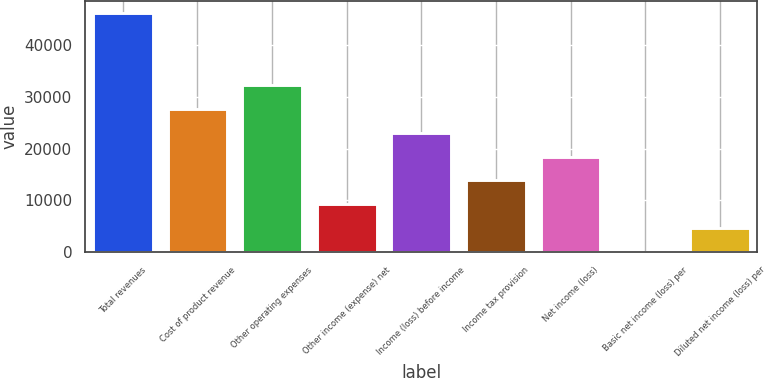<chart> <loc_0><loc_0><loc_500><loc_500><bar_chart><fcel>Total revenues<fcel>Cost of product revenue<fcel>Other operating expenses<fcel>Other income (expense) net<fcel>Income (loss) before income<fcel>Income tax provision<fcel>Net income (loss)<fcel>Basic net income (loss) per<fcel>Diluted net income (loss) per<nl><fcel>46195<fcel>27717<fcel>32336.5<fcel>9239.09<fcel>23097.6<fcel>13858.6<fcel>18478.1<fcel>0.11<fcel>4619.6<nl></chart> 